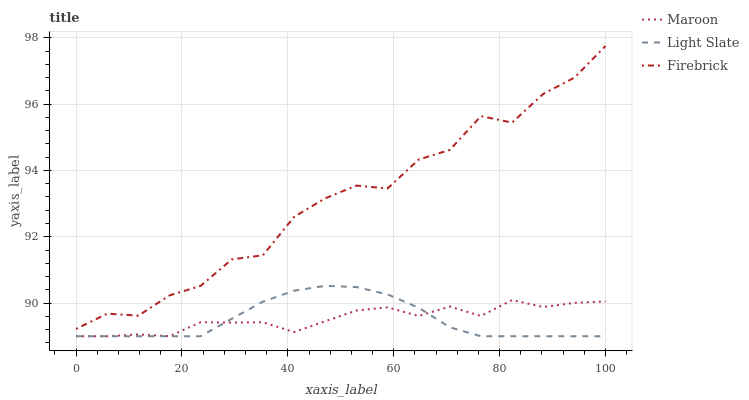Does Light Slate have the minimum area under the curve?
Answer yes or no. Yes. Does Firebrick have the maximum area under the curve?
Answer yes or no. Yes. Does Maroon have the minimum area under the curve?
Answer yes or no. No. Does Maroon have the maximum area under the curve?
Answer yes or no. No. Is Light Slate the smoothest?
Answer yes or no. Yes. Is Firebrick the roughest?
Answer yes or no. Yes. Is Maroon the smoothest?
Answer yes or no. No. Is Maroon the roughest?
Answer yes or no. No. Does Light Slate have the lowest value?
Answer yes or no. Yes. Does Firebrick have the lowest value?
Answer yes or no. No. Does Firebrick have the highest value?
Answer yes or no. Yes. Does Maroon have the highest value?
Answer yes or no. No. Is Maroon less than Firebrick?
Answer yes or no. Yes. Is Firebrick greater than Light Slate?
Answer yes or no. Yes. Does Maroon intersect Light Slate?
Answer yes or no. Yes. Is Maroon less than Light Slate?
Answer yes or no. No. Is Maroon greater than Light Slate?
Answer yes or no. No. Does Maroon intersect Firebrick?
Answer yes or no. No. 